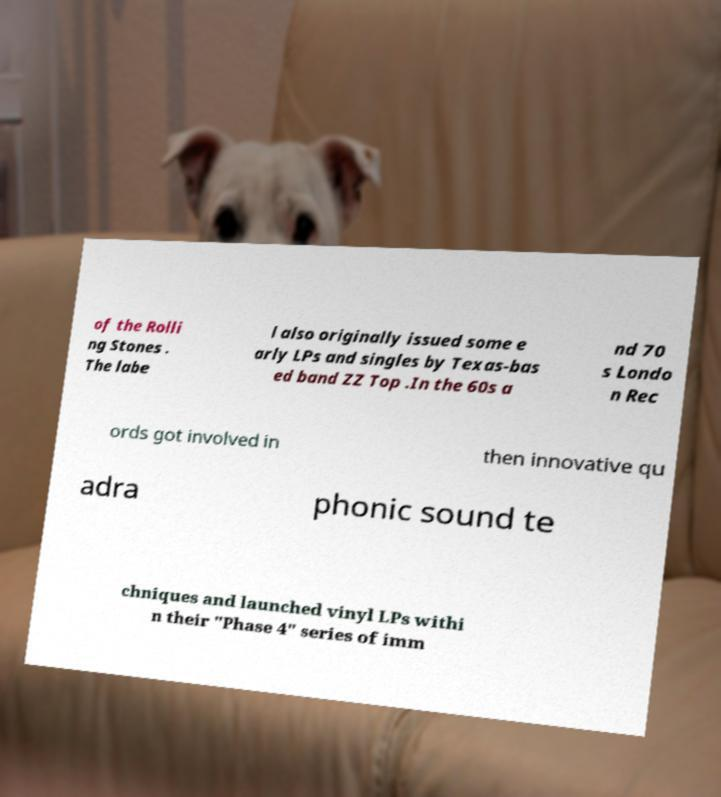Can you accurately transcribe the text from the provided image for me? of the Rolli ng Stones . The labe l also originally issued some e arly LPs and singles by Texas-bas ed band ZZ Top .In the 60s a nd 70 s Londo n Rec ords got involved in then innovative qu adra phonic sound te chniques and launched vinyl LPs withi n their "Phase 4" series of imm 